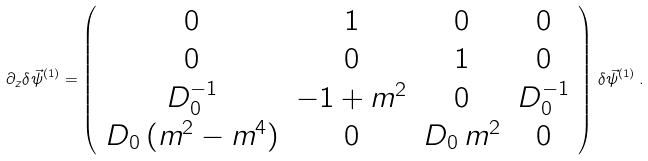Convert formula to latex. <formula><loc_0><loc_0><loc_500><loc_500>\partial _ { z } \delta \vec { \psi } ^ { ( 1 ) } = \left ( \begin{array} { c c c c } 0 & 1 & 0 & 0 \\ 0 & 0 & 1 & 0 \\ D _ { 0 } ^ { - 1 } & - 1 + m ^ { 2 } & 0 & D _ { 0 } ^ { - 1 } \\ D _ { 0 } \, ( m ^ { 2 } - m ^ { 4 } ) & 0 & D _ { 0 } \, m ^ { 2 } & 0 \end{array} \right ) \, \delta \vec { \psi } ^ { ( 1 ) } \, .</formula> 